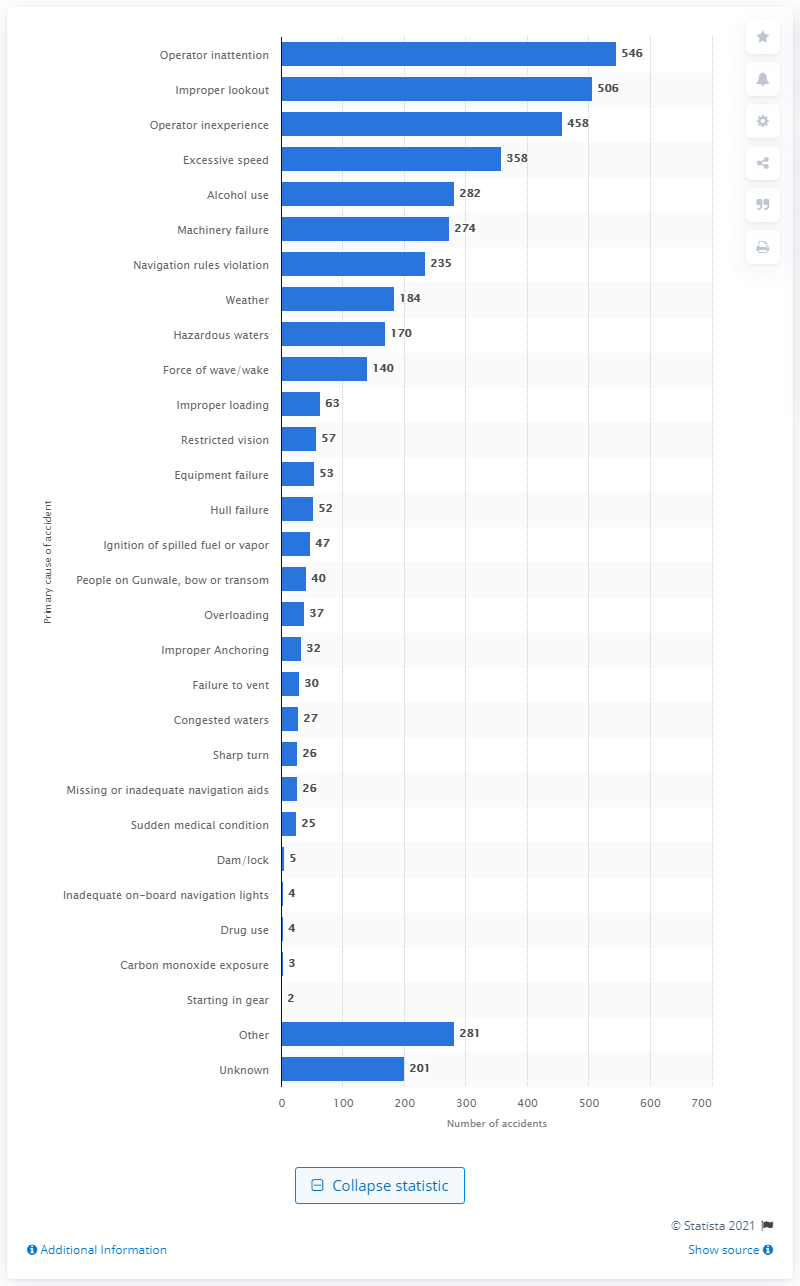Point out several critical features in this image. In 2019, there were 546 boating accidents in the United States. 